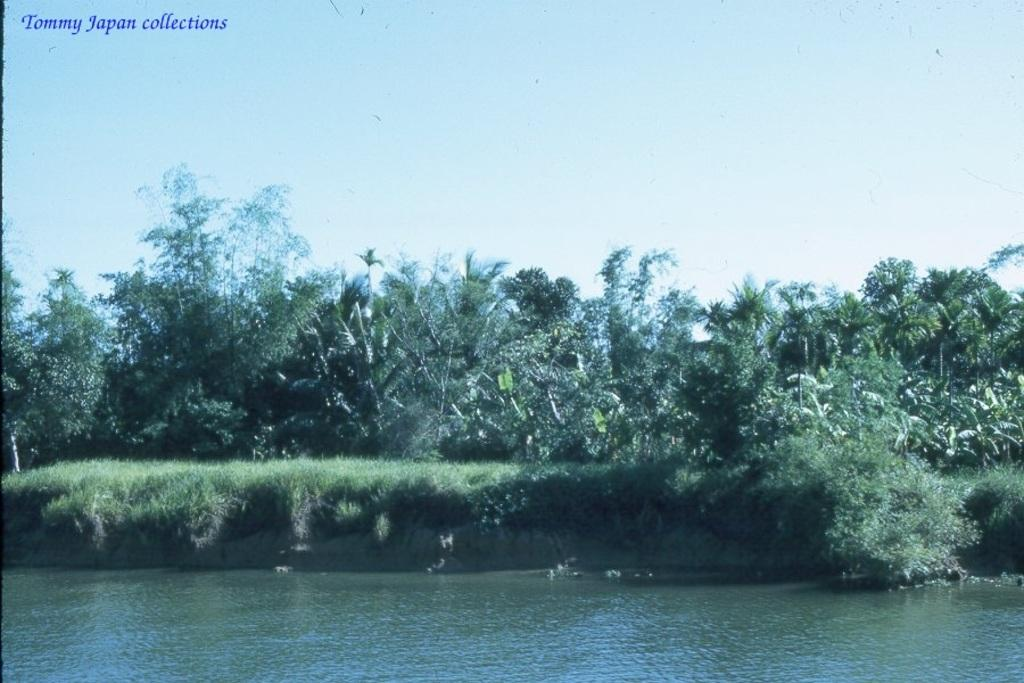What type of natural body of water is present in the image? There is a lake in the image. What other natural elements can be seen in the image? There is a group of trees and grass visible in the image. What is visible in the background of the image? The sky is visible in the background of the image. What type of neck accessory is being worn by the trees in the image? There are no neck accessories present in the image, as the trees are inanimate objects. Are any of the trees wearing masks in the image? There are no masks present in the image, as the trees are inanimate objects. 